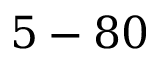Convert formula to latex. <formula><loc_0><loc_0><loc_500><loc_500>5 - 8 0</formula> 